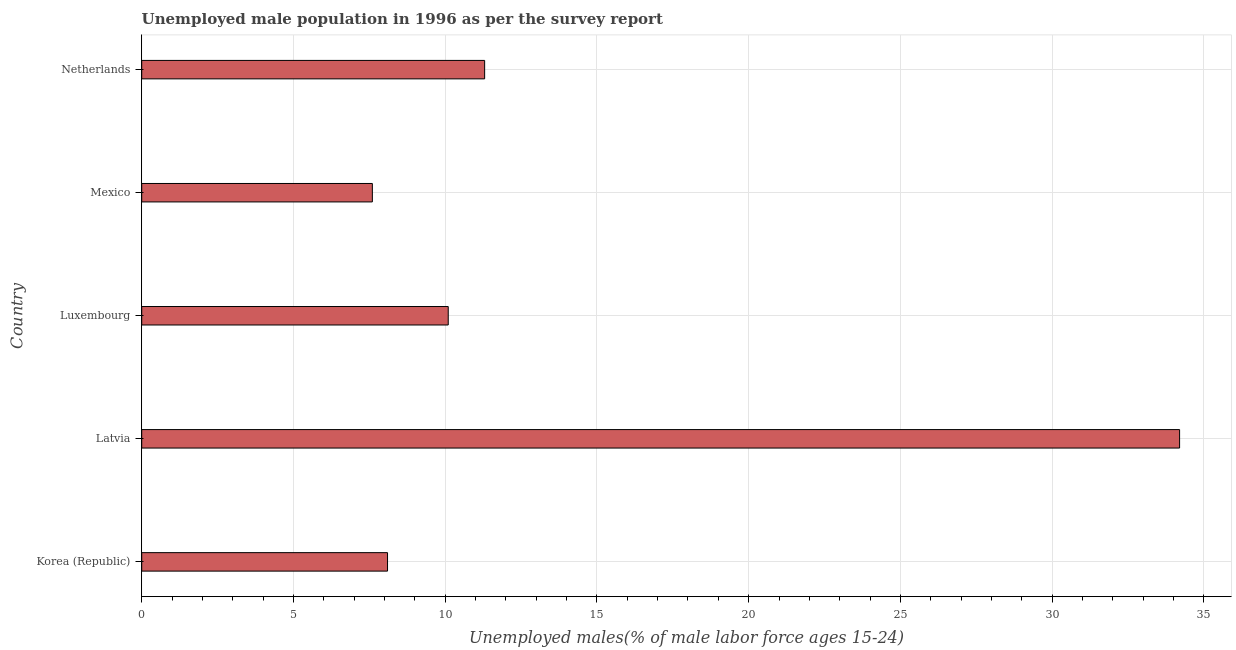Does the graph contain any zero values?
Give a very brief answer. No. What is the title of the graph?
Your response must be concise. Unemployed male population in 1996 as per the survey report. What is the label or title of the X-axis?
Offer a terse response. Unemployed males(% of male labor force ages 15-24). What is the label or title of the Y-axis?
Your answer should be compact. Country. What is the unemployed male youth in Mexico?
Your answer should be compact. 7.6. Across all countries, what is the maximum unemployed male youth?
Provide a succinct answer. 34.2. Across all countries, what is the minimum unemployed male youth?
Offer a very short reply. 7.6. In which country was the unemployed male youth maximum?
Your answer should be very brief. Latvia. What is the sum of the unemployed male youth?
Offer a terse response. 71.3. What is the average unemployed male youth per country?
Your answer should be very brief. 14.26. What is the median unemployed male youth?
Your response must be concise. 10.1. What is the ratio of the unemployed male youth in Korea (Republic) to that in Latvia?
Your answer should be compact. 0.24. Is the unemployed male youth in Mexico less than that in Netherlands?
Ensure brevity in your answer.  Yes. Is the difference between the unemployed male youth in Latvia and Luxembourg greater than the difference between any two countries?
Offer a terse response. No. What is the difference between the highest and the second highest unemployed male youth?
Your response must be concise. 22.9. Is the sum of the unemployed male youth in Korea (Republic) and Luxembourg greater than the maximum unemployed male youth across all countries?
Provide a short and direct response. No. What is the difference between the highest and the lowest unemployed male youth?
Give a very brief answer. 26.6. What is the Unemployed males(% of male labor force ages 15-24) in Korea (Republic)?
Give a very brief answer. 8.1. What is the Unemployed males(% of male labor force ages 15-24) in Latvia?
Offer a very short reply. 34.2. What is the Unemployed males(% of male labor force ages 15-24) in Luxembourg?
Ensure brevity in your answer.  10.1. What is the Unemployed males(% of male labor force ages 15-24) of Mexico?
Your answer should be compact. 7.6. What is the Unemployed males(% of male labor force ages 15-24) of Netherlands?
Provide a short and direct response. 11.3. What is the difference between the Unemployed males(% of male labor force ages 15-24) in Korea (Republic) and Latvia?
Make the answer very short. -26.1. What is the difference between the Unemployed males(% of male labor force ages 15-24) in Korea (Republic) and Luxembourg?
Make the answer very short. -2. What is the difference between the Unemployed males(% of male labor force ages 15-24) in Korea (Republic) and Mexico?
Provide a short and direct response. 0.5. What is the difference between the Unemployed males(% of male labor force ages 15-24) in Korea (Republic) and Netherlands?
Your answer should be very brief. -3.2. What is the difference between the Unemployed males(% of male labor force ages 15-24) in Latvia and Luxembourg?
Make the answer very short. 24.1. What is the difference between the Unemployed males(% of male labor force ages 15-24) in Latvia and Mexico?
Provide a succinct answer. 26.6. What is the difference between the Unemployed males(% of male labor force ages 15-24) in Latvia and Netherlands?
Your answer should be compact. 22.9. What is the difference between the Unemployed males(% of male labor force ages 15-24) in Luxembourg and Mexico?
Ensure brevity in your answer.  2.5. What is the difference between the Unemployed males(% of male labor force ages 15-24) in Luxembourg and Netherlands?
Offer a terse response. -1.2. What is the difference between the Unemployed males(% of male labor force ages 15-24) in Mexico and Netherlands?
Your response must be concise. -3.7. What is the ratio of the Unemployed males(% of male labor force ages 15-24) in Korea (Republic) to that in Latvia?
Your response must be concise. 0.24. What is the ratio of the Unemployed males(% of male labor force ages 15-24) in Korea (Republic) to that in Luxembourg?
Keep it short and to the point. 0.8. What is the ratio of the Unemployed males(% of male labor force ages 15-24) in Korea (Republic) to that in Mexico?
Ensure brevity in your answer.  1.07. What is the ratio of the Unemployed males(% of male labor force ages 15-24) in Korea (Republic) to that in Netherlands?
Keep it short and to the point. 0.72. What is the ratio of the Unemployed males(% of male labor force ages 15-24) in Latvia to that in Luxembourg?
Make the answer very short. 3.39. What is the ratio of the Unemployed males(% of male labor force ages 15-24) in Latvia to that in Netherlands?
Keep it short and to the point. 3.03. What is the ratio of the Unemployed males(% of male labor force ages 15-24) in Luxembourg to that in Mexico?
Give a very brief answer. 1.33. What is the ratio of the Unemployed males(% of male labor force ages 15-24) in Luxembourg to that in Netherlands?
Provide a succinct answer. 0.89. What is the ratio of the Unemployed males(% of male labor force ages 15-24) in Mexico to that in Netherlands?
Keep it short and to the point. 0.67. 